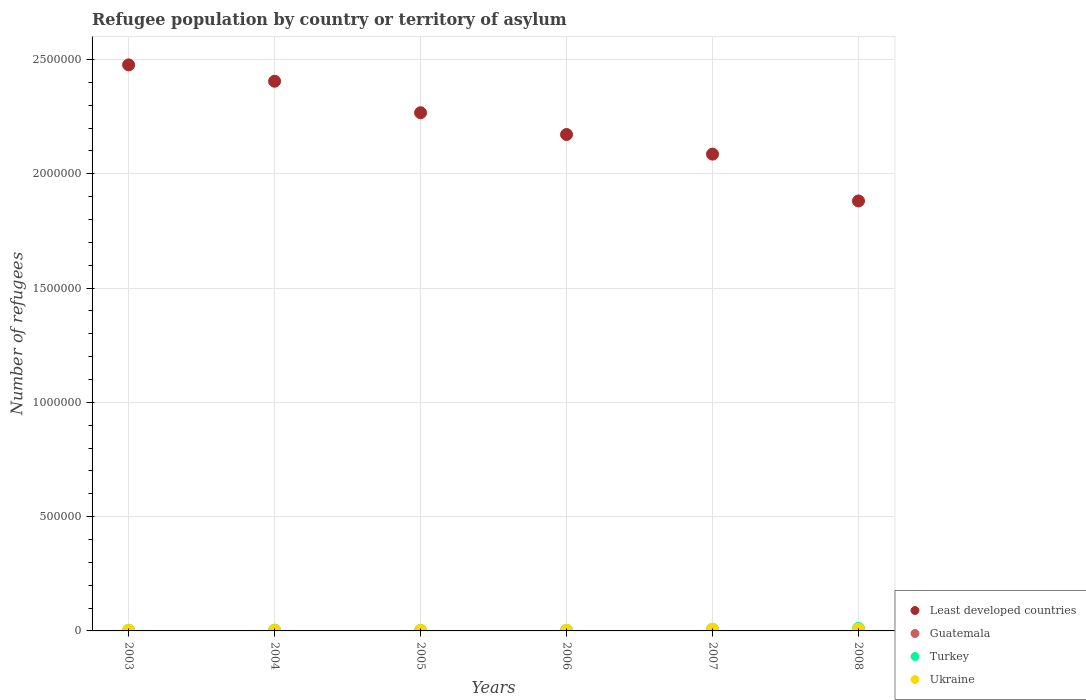What is the number of refugees in Guatemala in 2007?
Ensure brevity in your answer.  379. Across all years, what is the maximum number of refugees in Ukraine?
Provide a short and direct response. 7277. Across all years, what is the minimum number of refugees in Turkey?
Offer a terse response. 2399. What is the total number of refugees in Turkey in the graph?
Ensure brevity in your answer.  2.86e+04. What is the difference between the number of refugees in Ukraine in 2007 and that in 2008?
Provide a short and direct response. 76. What is the difference between the number of refugees in Turkey in 2004 and the number of refugees in Ukraine in 2007?
Ensure brevity in your answer.  -4244. What is the average number of refugees in Ukraine per year?
Keep it short and to the point. 4072.5. In the year 2006, what is the difference between the number of refugees in Turkey and number of refugees in Least developed countries?
Give a very brief answer. -2.17e+06. What is the ratio of the number of refugees in Guatemala in 2003 to that in 2006?
Give a very brief answer. 1.87. Is the number of refugees in Guatemala in 2003 less than that in 2004?
Provide a succinct answer. No. Is the difference between the number of refugees in Turkey in 2005 and 2006 greater than the difference between the number of refugees in Least developed countries in 2005 and 2006?
Give a very brief answer. No. What is the difference between the highest and the second highest number of refugees in Ukraine?
Your answer should be compact. 76. What is the difference between the highest and the lowest number of refugees in Turkey?
Offer a terse response. 8704. In how many years, is the number of refugees in Turkey greater than the average number of refugees in Turkey taken over all years?
Offer a terse response. 2. Is it the case that in every year, the sum of the number of refugees in Turkey and number of refugees in Least developed countries  is greater than the sum of number of refugees in Guatemala and number of refugees in Ukraine?
Keep it short and to the point. No. Is it the case that in every year, the sum of the number of refugees in Least developed countries and number of refugees in Ukraine  is greater than the number of refugees in Turkey?
Your answer should be compact. Yes. Is the number of refugees in Ukraine strictly greater than the number of refugees in Guatemala over the years?
Your answer should be very brief. Yes. Are the values on the major ticks of Y-axis written in scientific E-notation?
Provide a short and direct response. No. Does the graph contain grids?
Keep it short and to the point. Yes. How are the legend labels stacked?
Ensure brevity in your answer.  Vertical. What is the title of the graph?
Your response must be concise. Refugee population by country or territory of asylum. Does "Benin" appear as one of the legend labels in the graph?
Provide a short and direct response. No. What is the label or title of the Y-axis?
Your answer should be very brief. Number of refugees. What is the Number of refugees of Least developed countries in 2003?
Give a very brief answer. 2.48e+06. What is the Number of refugees of Guatemala in 2003?
Provide a short and direct response. 715. What is the Number of refugees in Turkey in 2003?
Keep it short and to the point. 2490. What is the Number of refugees in Ukraine in 2003?
Make the answer very short. 2877. What is the Number of refugees in Least developed countries in 2004?
Your answer should be compact. 2.40e+06. What is the Number of refugees in Guatemala in 2004?
Ensure brevity in your answer.  656. What is the Number of refugees in Turkey in 2004?
Keep it short and to the point. 3033. What is the Number of refugees of Ukraine in 2004?
Your answer should be compact. 2459. What is the Number of refugees of Least developed countries in 2005?
Make the answer very short. 2.27e+06. What is the Number of refugees in Guatemala in 2005?
Your answer should be very brief. 391. What is the Number of refugees of Turkey in 2005?
Offer a very short reply. 2399. What is the Number of refugees in Ukraine in 2005?
Give a very brief answer. 2346. What is the Number of refugees of Least developed countries in 2006?
Provide a short and direct response. 2.17e+06. What is the Number of refugees in Guatemala in 2006?
Keep it short and to the point. 382. What is the Number of refugees in Turkey in 2006?
Offer a very short reply. 2633. What is the Number of refugees in Ukraine in 2006?
Offer a very short reply. 2275. What is the Number of refugees in Least developed countries in 2007?
Make the answer very short. 2.09e+06. What is the Number of refugees of Guatemala in 2007?
Provide a short and direct response. 379. What is the Number of refugees of Turkey in 2007?
Your response must be concise. 6956. What is the Number of refugees in Ukraine in 2007?
Ensure brevity in your answer.  7277. What is the Number of refugees in Least developed countries in 2008?
Make the answer very short. 1.88e+06. What is the Number of refugees in Guatemala in 2008?
Offer a very short reply. 130. What is the Number of refugees in Turkey in 2008?
Provide a succinct answer. 1.11e+04. What is the Number of refugees in Ukraine in 2008?
Make the answer very short. 7201. Across all years, what is the maximum Number of refugees of Least developed countries?
Your response must be concise. 2.48e+06. Across all years, what is the maximum Number of refugees of Guatemala?
Offer a very short reply. 715. Across all years, what is the maximum Number of refugees in Turkey?
Keep it short and to the point. 1.11e+04. Across all years, what is the maximum Number of refugees of Ukraine?
Ensure brevity in your answer.  7277. Across all years, what is the minimum Number of refugees in Least developed countries?
Your answer should be very brief. 1.88e+06. Across all years, what is the minimum Number of refugees of Guatemala?
Provide a succinct answer. 130. Across all years, what is the minimum Number of refugees of Turkey?
Keep it short and to the point. 2399. Across all years, what is the minimum Number of refugees in Ukraine?
Keep it short and to the point. 2275. What is the total Number of refugees in Least developed countries in the graph?
Make the answer very short. 1.33e+07. What is the total Number of refugees in Guatemala in the graph?
Your answer should be very brief. 2653. What is the total Number of refugees in Turkey in the graph?
Offer a terse response. 2.86e+04. What is the total Number of refugees of Ukraine in the graph?
Make the answer very short. 2.44e+04. What is the difference between the Number of refugees of Least developed countries in 2003 and that in 2004?
Offer a very short reply. 7.16e+04. What is the difference between the Number of refugees in Guatemala in 2003 and that in 2004?
Provide a succinct answer. 59. What is the difference between the Number of refugees in Turkey in 2003 and that in 2004?
Your answer should be compact. -543. What is the difference between the Number of refugees of Ukraine in 2003 and that in 2004?
Provide a succinct answer. 418. What is the difference between the Number of refugees of Least developed countries in 2003 and that in 2005?
Offer a terse response. 2.09e+05. What is the difference between the Number of refugees in Guatemala in 2003 and that in 2005?
Provide a succinct answer. 324. What is the difference between the Number of refugees of Turkey in 2003 and that in 2005?
Provide a short and direct response. 91. What is the difference between the Number of refugees in Ukraine in 2003 and that in 2005?
Your answer should be compact. 531. What is the difference between the Number of refugees of Least developed countries in 2003 and that in 2006?
Keep it short and to the point. 3.05e+05. What is the difference between the Number of refugees of Guatemala in 2003 and that in 2006?
Offer a very short reply. 333. What is the difference between the Number of refugees of Turkey in 2003 and that in 2006?
Keep it short and to the point. -143. What is the difference between the Number of refugees of Ukraine in 2003 and that in 2006?
Offer a terse response. 602. What is the difference between the Number of refugees of Least developed countries in 2003 and that in 2007?
Give a very brief answer. 3.90e+05. What is the difference between the Number of refugees of Guatemala in 2003 and that in 2007?
Your response must be concise. 336. What is the difference between the Number of refugees of Turkey in 2003 and that in 2007?
Keep it short and to the point. -4466. What is the difference between the Number of refugees of Ukraine in 2003 and that in 2007?
Give a very brief answer. -4400. What is the difference between the Number of refugees in Least developed countries in 2003 and that in 2008?
Your answer should be very brief. 5.95e+05. What is the difference between the Number of refugees of Guatemala in 2003 and that in 2008?
Ensure brevity in your answer.  585. What is the difference between the Number of refugees in Turkey in 2003 and that in 2008?
Keep it short and to the point. -8613. What is the difference between the Number of refugees of Ukraine in 2003 and that in 2008?
Provide a succinct answer. -4324. What is the difference between the Number of refugees in Least developed countries in 2004 and that in 2005?
Provide a short and direct response. 1.38e+05. What is the difference between the Number of refugees in Guatemala in 2004 and that in 2005?
Give a very brief answer. 265. What is the difference between the Number of refugees of Turkey in 2004 and that in 2005?
Your answer should be compact. 634. What is the difference between the Number of refugees of Ukraine in 2004 and that in 2005?
Give a very brief answer. 113. What is the difference between the Number of refugees of Least developed countries in 2004 and that in 2006?
Keep it short and to the point. 2.33e+05. What is the difference between the Number of refugees in Guatemala in 2004 and that in 2006?
Your answer should be very brief. 274. What is the difference between the Number of refugees in Ukraine in 2004 and that in 2006?
Offer a very short reply. 184. What is the difference between the Number of refugees of Least developed countries in 2004 and that in 2007?
Keep it short and to the point. 3.19e+05. What is the difference between the Number of refugees in Guatemala in 2004 and that in 2007?
Provide a succinct answer. 277. What is the difference between the Number of refugees in Turkey in 2004 and that in 2007?
Offer a terse response. -3923. What is the difference between the Number of refugees of Ukraine in 2004 and that in 2007?
Your answer should be compact. -4818. What is the difference between the Number of refugees of Least developed countries in 2004 and that in 2008?
Ensure brevity in your answer.  5.24e+05. What is the difference between the Number of refugees in Guatemala in 2004 and that in 2008?
Your answer should be compact. 526. What is the difference between the Number of refugees in Turkey in 2004 and that in 2008?
Keep it short and to the point. -8070. What is the difference between the Number of refugees of Ukraine in 2004 and that in 2008?
Your response must be concise. -4742. What is the difference between the Number of refugees in Least developed countries in 2005 and that in 2006?
Your answer should be compact. 9.52e+04. What is the difference between the Number of refugees in Turkey in 2005 and that in 2006?
Offer a terse response. -234. What is the difference between the Number of refugees of Least developed countries in 2005 and that in 2007?
Ensure brevity in your answer.  1.81e+05. What is the difference between the Number of refugees of Guatemala in 2005 and that in 2007?
Offer a terse response. 12. What is the difference between the Number of refugees of Turkey in 2005 and that in 2007?
Offer a terse response. -4557. What is the difference between the Number of refugees in Ukraine in 2005 and that in 2007?
Keep it short and to the point. -4931. What is the difference between the Number of refugees in Least developed countries in 2005 and that in 2008?
Offer a very short reply. 3.86e+05. What is the difference between the Number of refugees in Guatemala in 2005 and that in 2008?
Keep it short and to the point. 261. What is the difference between the Number of refugees of Turkey in 2005 and that in 2008?
Make the answer very short. -8704. What is the difference between the Number of refugees of Ukraine in 2005 and that in 2008?
Offer a very short reply. -4855. What is the difference between the Number of refugees in Least developed countries in 2006 and that in 2007?
Your response must be concise. 8.58e+04. What is the difference between the Number of refugees in Guatemala in 2006 and that in 2007?
Keep it short and to the point. 3. What is the difference between the Number of refugees in Turkey in 2006 and that in 2007?
Offer a terse response. -4323. What is the difference between the Number of refugees of Ukraine in 2006 and that in 2007?
Make the answer very short. -5002. What is the difference between the Number of refugees in Least developed countries in 2006 and that in 2008?
Offer a terse response. 2.91e+05. What is the difference between the Number of refugees of Guatemala in 2006 and that in 2008?
Make the answer very short. 252. What is the difference between the Number of refugees of Turkey in 2006 and that in 2008?
Offer a very short reply. -8470. What is the difference between the Number of refugees of Ukraine in 2006 and that in 2008?
Make the answer very short. -4926. What is the difference between the Number of refugees in Least developed countries in 2007 and that in 2008?
Ensure brevity in your answer.  2.05e+05. What is the difference between the Number of refugees in Guatemala in 2007 and that in 2008?
Give a very brief answer. 249. What is the difference between the Number of refugees of Turkey in 2007 and that in 2008?
Keep it short and to the point. -4147. What is the difference between the Number of refugees in Least developed countries in 2003 and the Number of refugees in Guatemala in 2004?
Offer a terse response. 2.48e+06. What is the difference between the Number of refugees in Least developed countries in 2003 and the Number of refugees in Turkey in 2004?
Your answer should be very brief. 2.47e+06. What is the difference between the Number of refugees of Least developed countries in 2003 and the Number of refugees of Ukraine in 2004?
Give a very brief answer. 2.47e+06. What is the difference between the Number of refugees in Guatemala in 2003 and the Number of refugees in Turkey in 2004?
Make the answer very short. -2318. What is the difference between the Number of refugees in Guatemala in 2003 and the Number of refugees in Ukraine in 2004?
Your response must be concise. -1744. What is the difference between the Number of refugees in Turkey in 2003 and the Number of refugees in Ukraine in 2004?
Your answer should be compact. 31. What is the difference between the Number of refugees of Least developed countries in 2003 and the Number of refugees of Guatemala in 2005?
Ensure brevity in your answer.  2.48e+06. What is the difference between the Number of refugees of Least developed countries in 2003 and the Number of refugees of Turkey in 2005?
Your answer should be compact. 2.47e+06. What is the difference between the Number of refugees of Least developed countries in 2003 and the Number of refugees of Ukraine in 2005?
Your answer should be compact. 2.47e+06. What is the difference between the Number of refugees of Guatemala in 2003 and the Number of refugees of Turkey in 2005?
Provide a short and direct response. -1684. What is the difference between the Number of refugees of Guatemala in 2003 and the Number of refugees of Ukraine in 2005?
Make the answer very short. -1631. What is the difference between the Number of refugees of Turkey in 2003 and the Number of refugees of Ukraine in 2005?
Give a very brief answer. 144. What is the difference between the Number of refugees in Least developed countries in 2003 and the Number of refugees in Guatemala in 2006?
Ensure brevity in your answer.  2.48e+06. What is the difference between the Number of refugees of Least developed countries in 2003 and the Number of refugees of Turkey in 2006?
Make the answer very short. 2.47e+06. What is the difference between the Number of refugees in Least developed countries in 2003 and the Number of refugees in Ukraine in 2006?
Your answer should be compact. 2.47e+06. What is the difference between the Number of refugees of Guatemala in 2003 and the Number of refugees of Turkey in 2006?
Provide a short and direct response. -1918. What is the difference between the Number of refugees of Guatemala in 2003 and the Number of refugees of Ukraine in 2006?
Give a very brief answer. -1560. What is the difference between the Number of refugees of Turkey in 2003 and the Number of refugees of Ukraine in 2006?
Your answer should be very brief. 215. What is the difference between the Number of refugees of Least developed countries in 2003 and the Number of refugees of Guatemala in 2007?
Your response must be concise. 2.48e+06. What is the difference between the Number of refugees in Least developed countries in 2003 and the Number of refugees in Turkey in 2007?
Give a very brief answer. 2.47e+06. What is the difference between the Number of refugees in Least developed countries in 2003 and the Number of refugees in Ukraine in 2007?
Your answer should be very brief. 2.47e+06. What is the difference between the Number of refugees of Guatemala in 2003 and the Number of refugees of Turkey in 2007?
Offer a very short reply. -6241. What is the difference between the Number of refugees of Guatemala in 2003 and the Number of refugees of Ukraine in 2007?
Offer a terse response. -6562. What is the difference between the Number of refugees of Turkey in 2003 and the Number of refugees of Ukraine in 2007?
Your answer should be very brief. -4787. What is the difference between the Number of refugees of Least developed countries in 2003 and the Number of refugees of Guatemala in 2008?
Provide a short and direct response. 2.48e+06. What is the difference between the Number of refugees in Least developed countries in 2003 and the Number of refugees in Turkey in 2008?
Your answer should be very brief. 2.47e+06. What is the difference between the Number of refugees in Least developed countries in 2003 and the Number of refugees in Ukraine in 2008?
Make the answer very short. 2.47e+06. What is the difference between the Number of refugees in Guatemala in 2003 and the Number of refugees in Turkey in 2008?
Make the answer very short. -1.04e+04. What is the difference between the Number of refugees in Guatemala in 2003 and the Number of refugees in Ukraine in 2008?
Provide a short and direct response. -6486. What is the difference between the Number of refugees in Turkey in 2003 and the Number of refugees in Ukraine in 2008?
Your answer should be very brief. -4711. What is the difference between the Number of refugees in Least developed countries in 2004 and the Number of refugees in Guatemala in 2005?
Offer a very short reply. 2.40e+06. What is the difference between the Number of refugees in Least developed countries in 2004 and the Number of refugees in Turkey in 2005?
Your response must be concise. 2.40e+06. What is the difference between the Number of refugees of Least developed countries in 2004 and the Number of refugees of Ukraine in 2005?
Offer a very short reply. 2.40e+06. What is the difference between the Number of refugees of Guatemala in 2004 and the Number of refugees of Turkey in 2005?
Provide a short and direct response. -1743. What is the difference between the Number of refugees in Guatemala in 2004 and the Number of refugees in Ukraine in 2005?
Keep it short and to the point. -1690. What is the difference between the Number of refugees of Turkey in 2004 and the Number of refugees of Ukraine in 2005?
Keep it short and to the point. 687. What is the difference between the Number of refugees in Least developed countries in 2004 and the Number of refugees in Guatemala in 2006?
Your answer should be compact. 2.40e+06. What is the difference between the Number of refugees in Least developed countries in 2004 and the Number of refugees in Turkey in 2006?
Your answer should be compact. 2.40e+06. What is the difference between the Number of refugees in Least developed countries in 2004 and the Number of refugees in Ukraine in 2006?
Your response must be concise. 2.40e+06. What is the difference between the Number of refugees in Guatemala in 2004 and the Number of refugees in Turkey in 2006?
Make the answer very short. -1977. What is the difference between the Number of refugees in Guatemala in 2004 and the Number of refugees in Ukraine in 2006?
Offer a terse response. -1619. What is the difference between the Number of refugees of Turkey in 2004 and the Number of refugees of Ukraine in 2006?
Provide a short and direct response. 758. What is the difference between the Number of refugees of Least developed countries in 2004 and the Number of refugees of Guatemala in 2007?
Offer a very short reply. 2.40e+06. What is the difference between the Number of refugees in Least developed countries in 2004 and the Number of refugees in Turkey in 2007?
Give a very brief answer. 2.40e+06. What is the difference between the Number of refugees of Least developed countries in 2004 and the Number of refugees of Ukraine in 2007?
Ensure brevity in your answer.  2.40e+06. What is the difference between the Number of refugees of Guatemala in 2004 and the Number of refugees of Turkey in 2007?
Your answer should be compact. -6300. What is the difference between the Number of refugees of Guatemala in 2004 and the Number of refugees of Ukraine in 2007?
Your response must be concise. -6621. What is the difference between the Number of refugees in Turkey in 2004 and the Number of refugees in Ukraine in 2007?
Your response must be concise. -4244. What is the difference between the Number of refugees of Least developed countries in 2004 and the Number of refugees of Guatemala in 2008?
Your answer should be compact. 2.40e+06. What is the difference between the Number of refugees of Least developed countries in 2004 and the Number of refugees of Turkey in 2008?
Provide a short and direct response. 2.39e+06. What is the difference between the Number of refugees of Least developed countries in 2004 and the Number of refugees of Ukraine in 2008?
Your response must be concise. 2.40e+06. What is the difference between the Number of refugees of Guatemala in 2004 and the Number of refugees of Turkey in 2008?
Your response must be concise. -1.04e+04. What is the difference between the Number of refugees of Guatemala in 2004 and the Number of refugees of Ukraine in 2008?
Make the answer very short. -6545. What is the difference between the Number of refugees in Turkey in 2004 and the Number of refugees in Ukraine in 2008?
Provide a succinct answer. -4168. What is the difference between the Number of refugees in Least developed countries in 2005 and the Number of refugees in Guatemala in 2006?
Provide a short and direct response. 2.27e+06. What is the difference between the Number of refugees of Least developed countries in 2005 and the Number of refugees of Turkey in 2006?
Give a very brief answer. 2.26e+06. What is the difference between the Number of refugees in Least developed countries in 2005 and the Number of refugees in Ukraine in 2006?
Give a very brief answer. 2.26e+06. What is the difference between the Number of refugees in Guatemala in 2005 and the Number of refugees in Turkey in 2006?
Your response must be concise. -2242. What is the difference between the Number of refugees in Guatemala in 2005 and the Number of refugees in Ukraine in 2006?
Ensure brevity in your answer.  -1884. What is the difference between the Number of refugees of Turkey in 2005 and the Number of refugees of Ukraine in 2006?
Provide a short and direct response. 124. What is the difference between the Number of refugees of Least developed countries in 2005 and the Number of refugees of Guatemala in 2007?
Offer a very short reply. 2.27e+06. What is the difference between the Number of refugees in Least developed countries in 2005 and the Number of refugees in Turkey in 2007?
Keep it short and to the point. 2.26e+06. What is the difference between the Number of refugees of Least developed countries in 2005 and the Number of refugees of Ukraine in 2007?
Your answer should be compact. 2.26e+06. What is the difference between the Number of refugees of Guatemala in 2005 and the Number of refugees of Turkey in 2007?
Offer a very short reply. -6565. What is the difference between the Number of refugees in Guatemala in 2005 and the Number of refugees in Ukraine in 2007?
Give a very brief answer. -6886. What is the difference between the Number of refugees of Turkey in 2005 and the Number of refugees of Ukraine in 2007?
Provide a short and direct response. -4878. What is the difference between the Number of refugees of Least developed countries in 2005 and the Number of refugees of Guatemala in 2008?
Provide a succinct answer. 2.27e+06. What is the difference between the Number of refugees in Least developed countries in 2005 and the Number of refugees in Turkey in 2008?
Make the answer very short. 2.26e+06. What is the difference between the Number of refugees in Least developed countries in 2005 and the Number of refugees in Ukraine in 2008?
Give a very brief answer. 2.26e+06. What is the difference between the Number of refugees in Guatemala in 2005 and the Number of refugees in Turkey in 2008?
Give a very brief answer. -1.07e+04. What is the difference between the Number of refugees in Guatemala in 2005 and the Number of refugees in Ukraine in 2008?
Offer a terse response. -6810. What is the difference between the Number of refugees in Turkey in 2005 and the Number of refugees in Ukraine in 2008?
Your response must be concise. -4802. What is the difference between the Number of refugees in Least developed countries in 2006 and the Number of refugees in Guatemala in 2007?
Your answer should be very brief. 2.17e+06. What is the difference between the Number of refugees of Least developed countries in 2006 and the Number of refugees of Turkey in 2007?
Offer a terse response. 2.16e+06. What is the difference between the Number of refugees in Least developed countries in 2006 and the Number of refugees in Ukraine in 2007?
Your answer should be very brief. 2.16e+06. What is the difference between the Number of refugees in Guatemala in 2006 and the Number of refugees in Turkey in 2007?
Keep it short and to the point. -6574. What is the difference between the Number of refugees of Guatemala in 2006 and the Number of refugees of Ukraine in 2007?
Offer a very short reply. -6895. What is the difference between the Number of refugees of Turkey in 2006 and the Number of refugees of Ukraine in 2007?
Your answer should be compact. -4644. What is the difference between the Number of refugees in Least developed countries in 2006 and the Number of refugees in Guatemala in 2008?
Provide a short and direct response. 2.17e+06. What is the difference between the Number of refugees of Least developed countries in 2006 and the Number of refugees of Turkey in 2008?
Your response must be concise. 2.16e+06. What is the difference between the Number of refugees of Least developed countries in 2006 and the Number of refugees of Ukraine in 2008?
Make the answer very short. 2.16e+06. What is the difference between the Number of refugees in Guatemala in 2006 and the Number of refugees in Turkey in 2008?
Provide a succinct answer. -1.07e+04. What is the difference between the Number of refugees in Guatemala in 2006 and the Number of refugees in Ukraine in 2008?
Keep it short and to the point. -6819. What is the difference between the Number of refugees of Turkey in 2006 and the Number of refugees of Ukraine in 2008?
Give a very brief answer. -4568. What is the difference between the Number of refugees in Least developed countries in 2007 and the Number of refugees in Guatemala in 2008?
Provide a short and direct response. 2.09e+06. What is the difference between the Number of refugees in Least developed countries in 2007 and the Number of refugees in Turkey in 2008?
Give a very brief answer. 2.07e+06. What is the difference between the Number of refugees of Least developed countries in 2007 and the Number of refugees of Ukraine in 2008?
Keep it short and to the point. 2.08e+06. What is the difference between the Number of refugees of Guatemala in 2007 and the Number of refugees of Turkey in 2008?
Keep it short and to the point. -1.07e+04. What is the difference between the Number of refugees in Guatemala in 2007 and the Number of refugees in Ukraine in 2008?
Ensure brevity in your answer.  -6822. What is the difference between the Number of refugees in Turkey in 2007 and the Number of refugees in Ukraine in 2008?
Offer a terse response. -245. What is the average Number of refugees in Least developed countries per year?
Your response must be concise. 2.21e+06. What is the average Number of refugees in Guatemala per year?
Provide a short and direct response. 442.17. What is the average Number of refugees of Turkey per year?
Your answer should be compact. 4769. What is the average Number of refugees in Ukraine per year?
Offer a terse response. 4072.5. In the year 2003, what is the difference between the Number of refugees of Least developed countries and Number of refugees of Guatemala?
Provide a short and direct response. 2.48e+06. In the year 2003, what is the difference between the Number of refugees in Least developed countries and Number of refugees in Turkey?
Give a very brief answer. 2.47e+06. In the year 2003, what is the difference between the Number of refugees in Least developed countries and Number of refugees in Ukraine?
Offer a very short reply. 2.47e+06. In the year 2003, what is the difference between the Number of refugees in Guatemala and Number of refugees in Turkey?
Provide a short and direct response. -1775. In the year 2003, what is the difference between the Number of refugees of Guatemala and Number of refugees of Ukraine?
Your answer should be very brief. -2162. In the year 2003, what is the difference between the Number of refugees of Turkey and Number of refugees of Ukraine?
Ensure brevity in your answer.  -387. In the year 2004, what is the difference between the Number of refugees of Least developed countries and Number of refugees of Guatemala?
Offer a very short reply. 2.40e+06. In the year 2004, what is the difference between the Number of refugees in Least developed countries and Number of refugees in Turkey?
Ensure brevity in your answer.  2.40e+06. In the year 2004, what is the difference between the Number of refugees of Least developed countries and Number of refugees of Ukraine?
Give a very brief answer. 2.40e+06. In the year 2004, what is the difference between the Number of refugees of Guatemala and Number of refugees of Turkey?
Provide a short and direct response. -2377. In the year 2004, what is the difference between the Number of refugees in Guatemala and Number of refugees in Ukraine?
Your response must be concise. -1803. In the year 2004, what is the difference between the Number of refugees of Turkey and Number of refugees of Ukraine?
Offer a terse response. 574. In the year 2005, what is the difference between the Number of refugees of Least developed countries and Number of refugees of Guatemala?
Your answer should be very brief. 2.27e+06. In the year 2005, what is the difference between the Number of refugees in Least developed countries and Number of refugees in Turkey?
Your response must be concise. 2.26e+06. In the year 2005, what is the difference between the Number of refugees of Least developed countries and Number of refugees of Ukraine?
Your answer should be compact. 2.26e+06. In the year 2005, what is the difference between the Number of refugees in Guatemala and Number of refugees in Turkey?
Keep it short and to the point. -2008. In the year 2005, what is the difference between the Number of refugees of Guatemala and Number of refugees of Ukraine?
Offer a very short reply. -1955. In the year 2006, what is the difference between the Number of refugees of Least developed countries and Number of refugees of Guatemala?
Offer a terse response. 2.17e+06. In the year 2006, what is the difference between the Number of refugees in Least developed countries and Number of refugees in Turkey?
Your answer should be very brief. 2.17e+06. In the year 2006, what is the difference between the Number of refugees of Least developed countries and Number of refugees of Ukraine?
Ensure brevity in your answer.  2.17e+06. In the year 2006, what is the difference between the Number of refugees of Guatemala and Number of refugees of Turkey?
Provide a short and direct response. -2251. In the year 2006, what is the difference between the Number of refugees of Guatemala and Number of refugees of Ukraine?
Offer a very short reply. -1893. In the year 2006, what is the difference between the Number of refugees of Turkey and Number of refugees of Ukraine?
Your answer should be compact. 358. In the year 2007, what is the difference between the Number of refugees in Least developed countries and Number of refugees in Guatemala?
Keep it short and to the point. 2.09e+06. In the year 2007, what is the difference between the Number of refugees in Least developed countries and Number of refugees in Turkey?
Give a very brief answer. 2.08e+06. In the year 2007, what is the difference between the Number of refugees of Least developed countries and Number of refugees of Ukraine?
Provide a short and direct response. 2.08e+06. In the year 2007, what is the difference between the Number of refugees of Guatemala and Number of refugees of Turkey?
Give a very brief answer. -6577. In the year 2007, what is the difference between the Number of refugees in Guatemala and Number of refugees in Ukraine?
Give a very brief answer. -6898. In the year 2007, what is the difference between the Number of refugees in Turkey and Number of refugees in Ukraine?
Provide a succinct answer. -321. In the year 2008, what is the difference between the Number of refugees in Least developed countries and Number of refugees in Guatemala?
Offer a terse response. 1.88e+06. In the year 2008, what is the difference between the Number of refugees in Least developed countries and Number of refugees in Turkey?
Your answer should be compact. 1.87e+06. In the year 2008, what is the difference between the Number of refugees of Least developed countries and Number of refugees of Ukraine?
Your response must be concise. 1.87e+06. In the year 2008, what is the difference between the Number of refugees of Guatemala and Number of refugees of Turkey?
Provide a short and direct response. -1.10e+04. In the year 2008, what is the difference between the Number of refugees in Guatemala and Number of refugees in Ukraine?
Give a very brief answer. -7071. In the year 2008, what is the difference between the Number of refugees in Turkey and Number of refugees in Ukraine?
Your response must be concise. 3902. What is the ratio of the Number of refugees in Least developed countries in 2003 to that in 2004?
Offer a very short reply. 1.03. What is the ratio of the Number of refugees in Guatemala in 2003 to that in 2004?
Your answer should be compact. 1.09. What is the ratio of the Number of refugees in Turkey in 2003 to that in 2004?
Keep it short and to the point. 0.82. What is the ratio of the Number of refugees in Ukraine in 2003 to that in 2004?
Provide a succinct answer. 1.17. What is the ratio of the Number of refugees in Least developed countries in 2003 to that in 2005?
Offer a terse response. 1.09. What is the ratio of the Number of refugees in Guatemala in 2003 to that in 2005?
Make the answer very short. 1.83. What is the ratio of the Number of refugees of Turkey in 2003 to that in 2005?
Make the answer very short. 1.04. What is the ratio of the Number of refugees in Ukraine in 2003 to that in 2005?
Give a very brief answer. 1.23. What is the ratio of the Number of refugees in Least developed countries in 2003 to that in 2006?
Make the answer very short. 1.14. What is the ratio of the Number of refugees of Guatemala in 2003 to that in 2006?
Your answer should be very brief. 1.87. What is the ratio of the Number of refugees of Turkey in 2003 to that in 2006?
Your answer should be compact. 0.95. What is the ratio of the Number of refugees of Ukraine in 2003 to that in 2006?
Give a very brief answer. 1.26. What is the ratio of the Number of refugees in Least developed countries in 2003 to that in 2007?
Give a very brief answer. 1.19. What is the ratio of the Number of refugees in Guatemala in 2003 to that in 2007?
Provide a short and direct response. 1.89. What is the ratio of the Number of refugees in Turkey in 2003 to that in 2007?
Ensure brevity in your answer.  0.36. What is the ratio of the Number of refugees in Ukraine in 2003 to that in 2007?
Ensure brevity in your answer.  0.4. What is the ratio of the Number of refugees in Least developed countries in 2003 to that in 2008?
Give a very brief answer. 1.32. What is the ratio of the Number of refugees in Turkey in 2003 to that in 2008?
Provide a short and direct response. 0.22. What is the ratio of the Number of refugees of Ukraine in 2003 to that in 2008?
Offer a terse response. 0.4. What is the ratio of the Number of refugees in Least developed countries in 2004 to that in 2005?
Your answer should be compact. 1.06. What is the ratio of the Number of refugees in Guatemala in 2004 to that in 2005?
Keep it short and to the point. 1.68. What is the ratio of the Number of refugees of Turkey in 2004 to that in 2005?
Keep it short and to the point. 1.26. What is the ratio of the Number of refugees in Ukraine in 2004 to that in 2005?
Give a very brief answer. 1.05. What is the ratio of the Number of refugees in Least developed countries in 2004 to that in 2006?
Ensure brevity in your answer.  1.11. What is the ratio of the Number of refugees of Guatemala in 2004 to that in 2006?
Make the answer very short. 1.72. What is the ratio of the Number of refugees in Turkey in 2004 to that in 2006?
Ensure brevity in your answer.  1.15. What is the ratio of the Number of refugees in Ukraine in 2004 to that in 2006?
Keep it short and to the point. 1.08. What is the ratio of the Number of refugees in Least developed countries in 2004 to that in 2007?
Your answer should be very brief. 1.15. What is the ratio of the Number of refugees in Guatemala in 2004 to that in 2007?
Your answer should be very brief. 1.73. What is the ratio of the Number of refugees in Turkey in 2004 to that in 2007?
Your response must be concise. 0.44. What is the ratio of the Number of refugees in Ukraine in 2004 to that in 2007?
Your response must be concise. 0.34. What is the ratio of the Number of refugees in Least developed countries in 2004 to that in 2008?
Your answer should be very brief. 1.28. What is the ratio of the Number of refugees in Guatemala in 2004 to that in 2008?
Offer a terse response. 5.05. What is the ratio of the Number of refugees of Turkey in 2004 to that in 2008?
Make the answer very short. 0.27. What is the ratio of the Number of refugees of Ukraine in 2004 to that in 2008?
Give a very brief answer. 0.34. What is the ratio of the Number of refugees in Least developed countries in 2005 to that in 2006?
Offer a terse response. 1.04. What is the ratio of the Number of refugees in Guatemala in 2005 to that in 2006?
Ensure brevity in your answer.  1.02. What is the ratio of the Number of refugees of Turkey in 2005 to that in 2006?
Provide a succinct answer. 0.91. What is the ratio of the Number of refugees of Ukraine in 2005 to that in 2006?
Give a very brief answer. 1.03. What is the ratio of the Number of refugees in Least developed countries in 2005 to that in 2007?
Your response must be concise. 1.09. What is the ratio of the Number of refugees of Guatemala in 2005 to that in 2007?
Keep it short and to the point. 1.03. What is the ratio of the Number of refugees of Turkey in 2005 to that in 2007?
Ensure brevity in your answer.  0.34. What is the ratio of the Number of refugees in Ukraine in 2005 to that in 2007?
Ensure brevity in your answer.  0.32. What is the ratio of the Number of refugees of Least developed countries in 2005 to that in 2008?
Provide a short and direct response. 1.21. What is the ratio of the Number of refugees of Guatemala in 2005 to that in 2008?
Provide a short and direct response. 3.01. What is the ratio of the Number of refugees of Turkey in 2005 to that in 2008?
Give a very brief answer. 0.22. What is the ratio of the Number of refugees in Ukraine in 2005 to that in 2008?
Offer a very short reply. 0.33. What is the ratio of the Number of refugees of Least developed countries in 2006 to that in 2007?
Offer a very short reply. 1.04. What is the ratio of the Number of refugees in Guatemala in 2006 to that in 2007?
Ensure brevity in your answer.  1.01. What is the ratio of the Number of refugees of Turkey in 2006 to that in 2007?
Your answer should be compact. 0.38. What is the ratio of the Number of refugees of Ukraine in 2006 to that in 2007?
Ensure brevity in your answer.  0.31. What is the ratio of the Number of refugees of Least developed countries in 2006 to that in 2008?
Your response must be concise. 1.15. What is the ratio of the Number of refugees of Guatemala in 2006 to that in 2008?
Offer a very short reply. 2.94. What is the ratio of the Number of refugees in Turkey in 2006 to that in 2008?
Make the answer very short. 0.24. What is the ratio of the Number of refugees of Ukraine in 2006 to that in 2008?
Give a very brief answer. 0.32. What is the ratio of the Number of refugees in Least developed countries in 2007 to that in 2008?
Your answer should be compact. 1.11. What is the ratio of the Number of refugees of Guatemala in 2007 to that in 2008?
Offer a very short reply. 2.92. What is the ratio of the Number of refugees of Turkey in 2007 to that in 2008?
Offer a very short reply. 0.63. What is the ratio of the Number of refugees in Ukraine in 2007 to that in 2008?
Your answer should be very brief. 1.01. What is the difference between the highest and the second highest Number of refugees in Least developed countries?
Give a very brief answer. 7.16e+04. What is the difference between the highest and the second highest Number of refugees of Turkey?
Your answer should be very brief. 4147. What is the difference between the highest and the lowest Number of refugees in Least developed countries?
Offer a terse response. 5.95e+05. What is the difference between the highest and the lowest Number of refugees of Guatemala?
Offer a terse response. 585. What is the difference between the highest and the lowest Number of refugees of Turkey?
Your response must be concise. 8704. What is the difference between the highest and the lowest Number of refugees in Ukraine?
Offer a very short reply. 5002. 